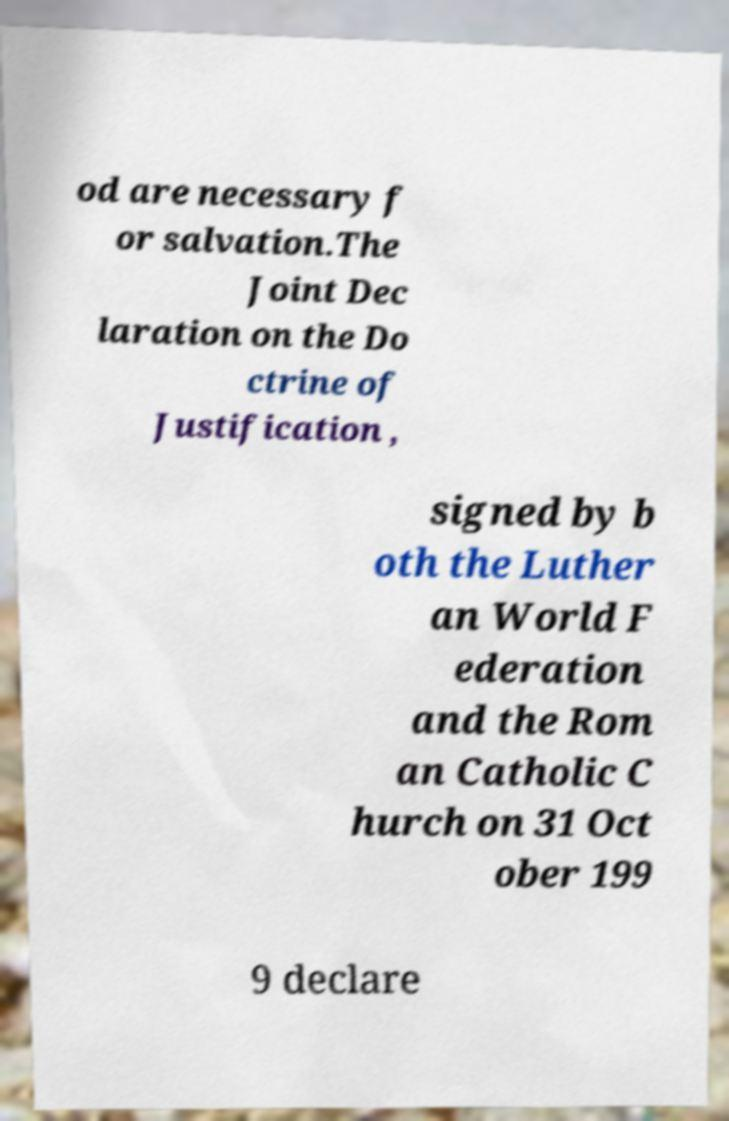Please read and relay the text visible in this image. What does it say? od are necessary f or salvation.The Joint Dec laration on the Do ctrine of Justification , signed by b oth the Luther an World F ederation and the Rom an Catholic C hurch on 31 Oct ober 199 9 declare 